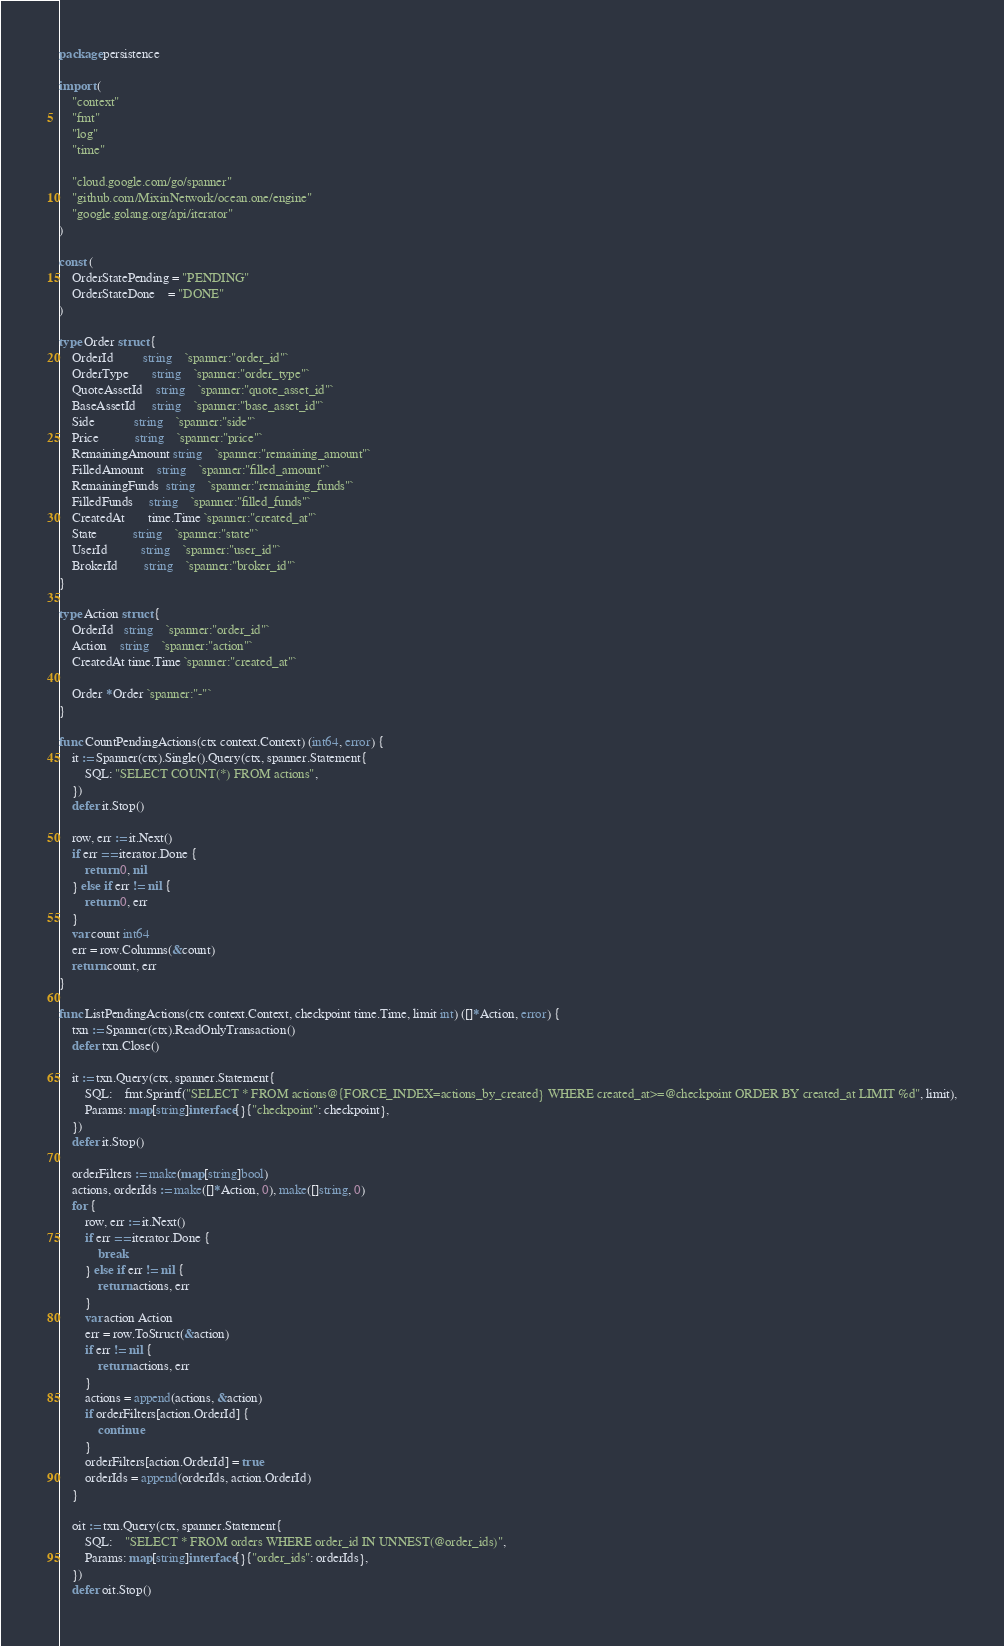<code> <loc_0><loc_0><loc_500><loc_500><_Go_>package persistence

import (
	"context"
	"fmt"
	"log"
	"time"

	"cloud.google.com/go/spanner"
	"github.com/MixinNetwork/ocean.one/engine"
	"google.golang.org/api/iterator"
)

const (
	OrderStatePending = "PENDING"
	OrderStateDone    = "DONE"
)

type Order struct {
	OrderId         string    `spanner:"order_id"`
	OrderType       string    `spanner:"order_type"`
	QuoteAssetId    string    `spanner:"quote_asset_id"`
	BaseAssetId     string    `spanner:"base_asset_id"`
	Side            string    `spanner:"side"`
	Price           string    `spanner:"price"`
	RemainingAmount string    `spanner:"remaining_amount"`
	FilledAmount    string    `spanner:"filled_amount"`
	RemainingFunds  string    `spanner:"remaining_funds"`
	FilledFunds     string    `spanner:"filled_funds"`
	CreatedAt       time.Time `spanner:"created_at"`
	State           string    `spanner:"state"`
	UserId          string    `spanner:"user_id"`
	BrokerId        string    `spanner:"broker_id"`
}

type Action struct {
	OrderId   string    `spanner:"order_id"`
	Action    string    `spanner:"action"`
	CreatedAt time.Time `spanner:"created_at"`

	Order *Order `spanner:"-"`
}

func CountPendingActions(ctx context.Context) (int64, error) {
	it := Spanner(ctx).Single().Query(ctx, spanner.Statement{
		SQL: "SELECT COUNT(*) FROM actions",
	})
	defer it.Stop()

	row, err := it.Next()
	if err == iterator.Done {
		return 0, nil
	} else if err != nil {
		return 0, err
	}
	var count int64
	err = row.Columns(&count)
	return count, err
}

func ListPendingActions(ctx context.Context, checkpoint time.Time, limit int) ([]*Action, error) {
	txn := Spanner(ctx).ReadOnlyTransaction()
	defer txn.Close()

	it := txn.Query(ctx, spanner.Statement{
		SQL:    fmt.Sprintf("SELECT * FROM actions@{FORCE_INDEX=actions_by_created} WHERE created_at>=@checkpoint ORDER BY created_at LIMIT %d", limit),
		Params: map[string]interface{}{"checkpoint": checkpoint},
	})
	defer it.Stop()

	orderFilters := make(map[string]bool)
	actions, orderIds := make([]*Action, 0), make([]string, 0)
	for {
		row, err := it.Next()
		if err == iterator.Done {
			break
		} else if err != nil {
			return actions, err
		}
		var action Action
		err = row.ToStruct(&action)
		if err != nil {
			return actions, err
		}
		actions = append(actions, &action)
		if orderFilters[action.OrderId] {
			continue
		}
		orderFilters[action.OrderId] = true
		orderIds = append(orderIds, action.OrderId)
	}

	oit := txn.Query(ctx, spanner.Statement{
		SQL:    "SELECT * FROM orders WHERE order_id IN UNNEST(@order_ids)",
		Params: map[string]interface{}{"order_ids": orderIds},
	})
	defer oit.Stop()
</code> 